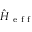Convert formula to latex. <formula><loc_0><loc_0><loc_500><loc_500>\hat { H } _ { e f f }</formula> 